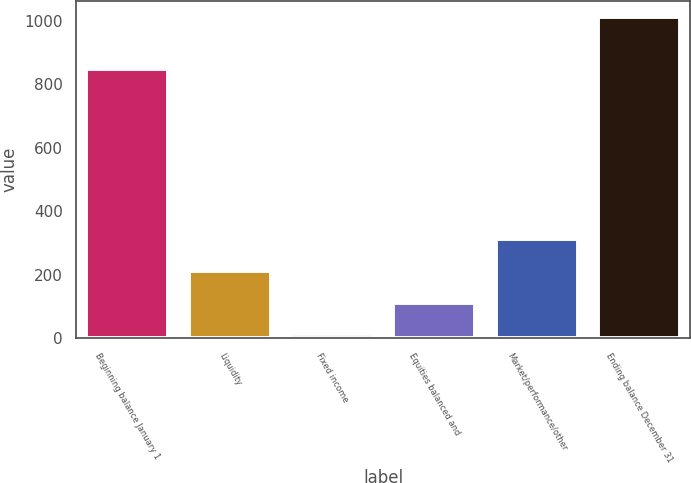Convert chart. <chart><loc_0><loc_0><loc_500><loc_500><bar_chart><fcel>Beginning balance January 1<fcel>Liquidity<fcel>Fixed income<fcel>Equities balanced and<fcel>Market/performance/other<fcel>Ending balance December 31<nl><fcel>847<fcel>211.4<fcel>11<fcel>111.2<fcel>311.6<fcel>1013<nl></chart> 